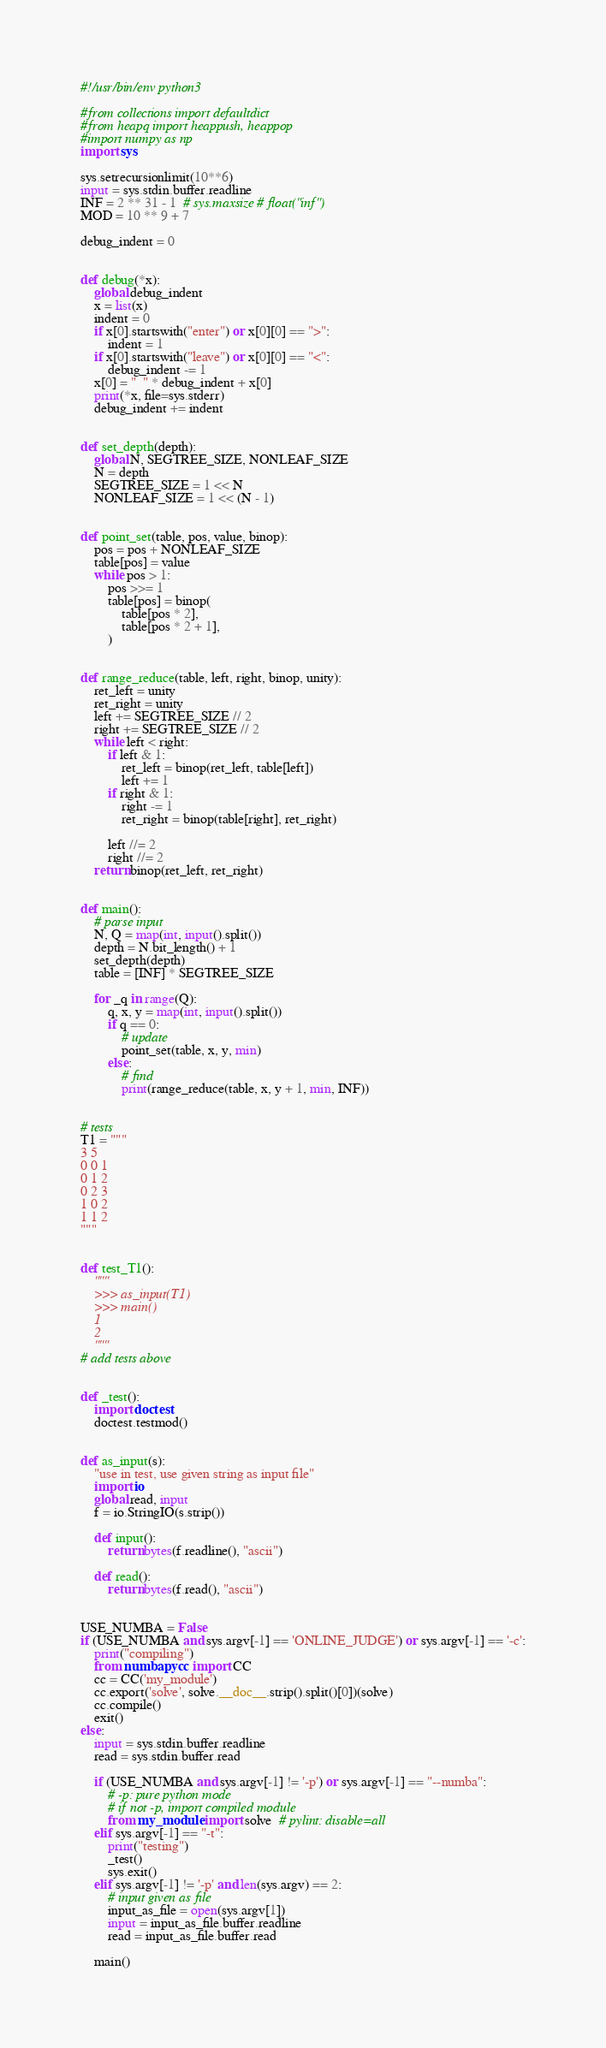<code> <loc_0><loc_0><loc_500><loc_500><_Python_>#!/usr/bin/env python3

#from collections import defaultdict
#from heapq import heappush, heappop
#import numpy as np
import sys

sys.setrecursionlimit(10**6)
input = sys.stdin.buffer.readline
INF = 2 ** 31 - 1  # sys.maxsize # float("inf")
MOD = 10 ** 9 + 7

debug_indent = 0


def debug(*x):
    global debug_indent
    x = list(x)
    indent = 0
    if x[0].startswith("enter") or x[0][0] == ">":
        indent = 1
    if x[0].startswith("leave") or x[0][0] == "<":
        debug_indent -= 1
    x[0] = "  " * debug_indent + x[0]
    print(*x, file=sys.stderr)
    debug_indent += indent


def set_depth(depth):
    global N, SEGTREE_SIZE, NONLEAF_SIZE
    N = depth
    SEGTREE_SIZE = 1 << N
    NONLEAF_SIZE = 1 << (N - 1)


def point_set(table, pos, value, binop):
    pos = pos + NONLEAF_SIZE
    table[pos] = value
    while pos > 1:
        pos >>= 1
        table[pos] = binop(
            table[pos * 2],
            table[pos * 2 + 1],
        )


def range_reduce(table, left, right, binop, unity):
    ret_left = unity
    ret_right = unity
    left += SEGTREE_SIZE // 2
    right += SEGTREE_SIZE // 2
    while left < right:
        if left & 1:
            ret_left = binop(ret_left, table[left])
            left += 1
        if right & 1:
            right -= 1
            ret_right = binop(table[right], ret_right)

        left //= 2
        right //= 2
    return binop(ret_left, ret_right)


def main():
    # parse input
    N, Q = map(int, input().split())
    depth = N.bit_length() + 1
    set_depth(depth)
    table = [INF] * SEGTREE_SIZE

    for _q in range(Q):
        q, x, y = map(int, input().split())
        if q == 0:
            # update
            point_set(table, x, y, min)
        else:
            # find
            print(range_reduce(table, x, y + 1, min, INF))


# tests
T1 = """
3 5
0 0 1
0 1 2
0 2 3
1 0 2
1 1 2
"""


def test_T1():
    """
    >>> as_input(T1)
    >>> main()
    1
    2
    """
# add tests above


def _test():
    import doctest
    doctest.testmod()


def as_input(s):
    "use in test, use given string as input file"
    import io
    global read, input
    f = io.StringIO(s.strip())

    def input():
        return bytes(f.readline(), "ascii")

    def read():
        return bytes(f.read(), "ascii")


USE_NUMBA = False
if (USE_NUMBA and sys.argv[-1] == 'ONLINE_JUDGE') or sys.argv[-1] == '-c':
    print("compiling")
    from numba.pycc import CC
    cc = CC('my_module')
    cc.export('solve', solve.__doc__.strip().split()[0])(solve)
    cc.compile()
    exit()
else:
    input = sys.stdin.buffer.readline
    read = sys.stdin.buffer.read

    if (USE_NUMBA and sys.argv[-1] != '-p') or sys.argv[-1] == "--numba":
        # -p: pure python mode
        # if not -p, import compiled module
        from my_module import solve  # pylint: disable=all
    elif sys.argv[-1] == "-t":
        print("testing")
        _test()
        sys.exit()
    elif sys.argv[-1] != '-p' and len(sys.argv) == 2:
        # input given as file
        input_as_file = open(sys.argv[1])
        input = input_as_file.buffer.readline
        read = input_as_file.buffer.read

    main()

</code> 